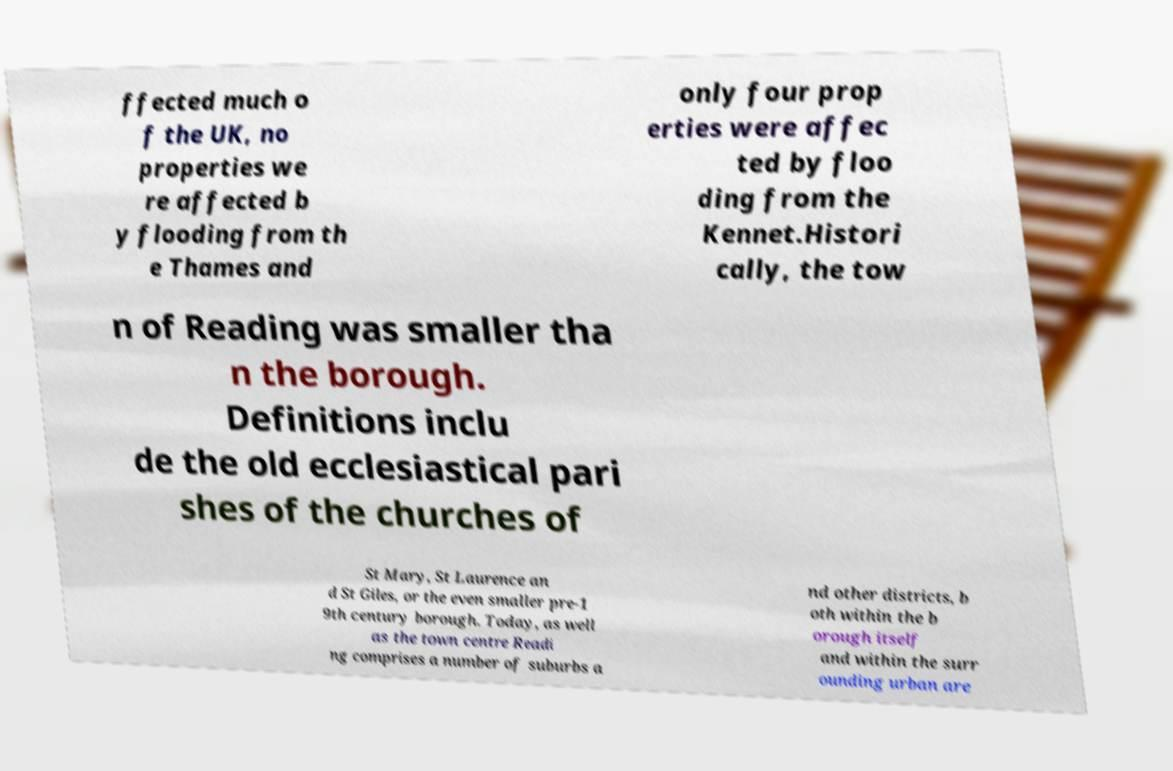Can you read and provide the text displayed in the image?This photo seems to have some interesting text. Can you extract and type it out for me? ffected much o f the UK, no properties we re affected b y flooding from th e Thames and only four prop erties were affec ted by floo ding from the Kennet.Histori cally, the tow n of Reading was smaller tha n the borough. Definitions inclu de the old ecclesiastical pari shes of the churches of St Mary, St Laurence an d St Giles, or the even smaller pre-1 9th century borough. Today, as well as the town centre Readi ng comprises a number of suburbs a nd other districts, b oth within the b orough itself and within the surr ounding urban are 